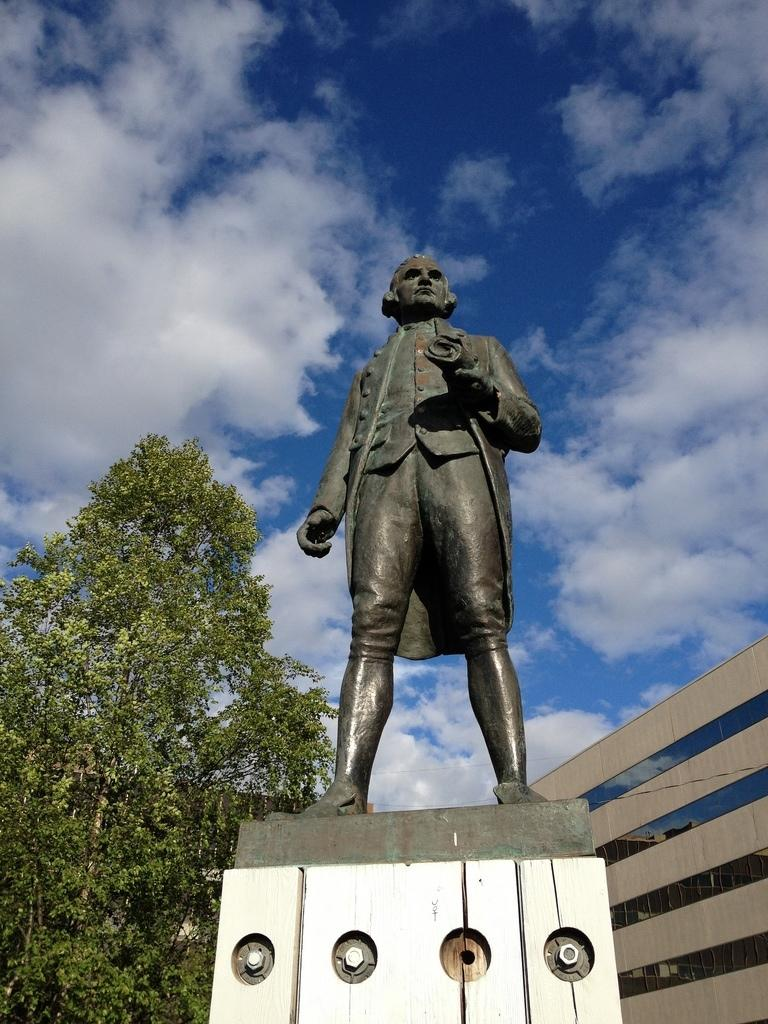What is the main subject in the foreground of the picture? There is a statue in the foreground of the picture. What can be seen on the right side of the picture? There is a building on the right side of the picture. What type of vegetation is on the left side of the picture? There are trees on the left side of the picture. How would you describe the sky in the picture? The sky is cloudy in the picture. What type of substance is being used to play volleyball in the image? There is no volleyball or substance being used for playing in the image; it features a statue, a building, trees, and a cloudy sky. 